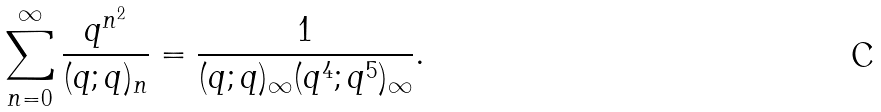<formula> <loc_0><loc_0><loc_500><loc_500>\sum _ { n = 0 } ^ { \infty } \frac { q ^ { n ^ { 2 } } } { ( q ; q ) _ { n } } & = \frac { 1 } { ( q ; q ) _ { \infty } ( q ^ { 4 } ; q ^ { 5 } ) _ { \infty } } .</formula> 